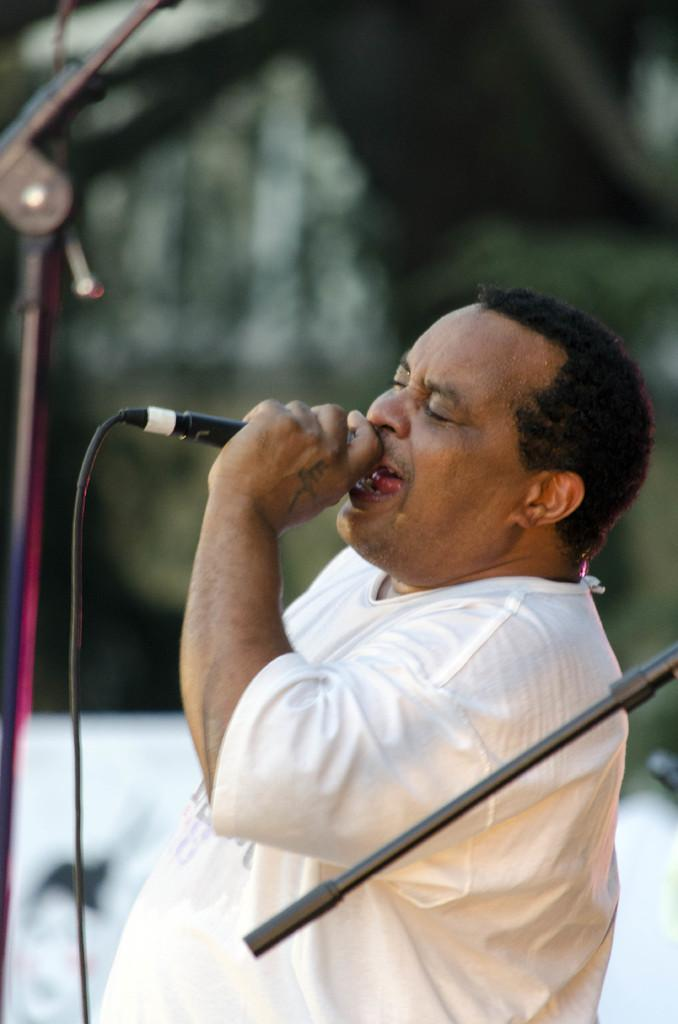What is the man in the image doing? The man is singing in the image. What object is the man holding in his hand? The man is holding a mic in his hand. Why is the man crying while singing in the image? The man is not crying in the image; he is singing. 